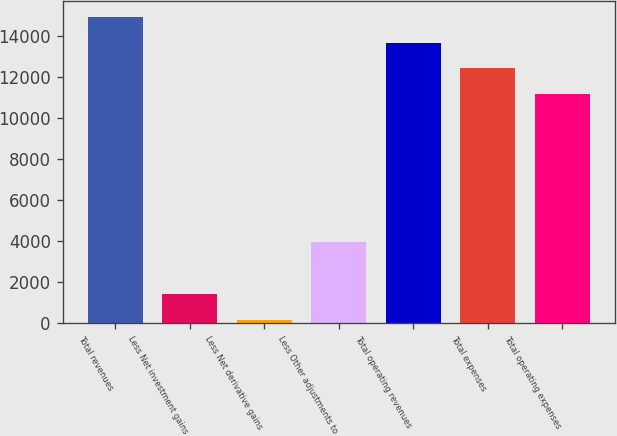<chart> <loc_0><loc_0><loc_500><loc_500><bar_chart><fcel>Total revenues<fcel>Less Net investment gains<fcel>Less Net derivative gains<fcel>Less Other adjustments to<fcel>Total operating revenues<fcel>Total expenses<fcel>Total operating expenses<nl><fcel>14951.9<fcel>1432.3<fcel>170<fcel>3956.9<fcel>13689.6<fcel>12427.3<fcel>11165<nl></chart> 